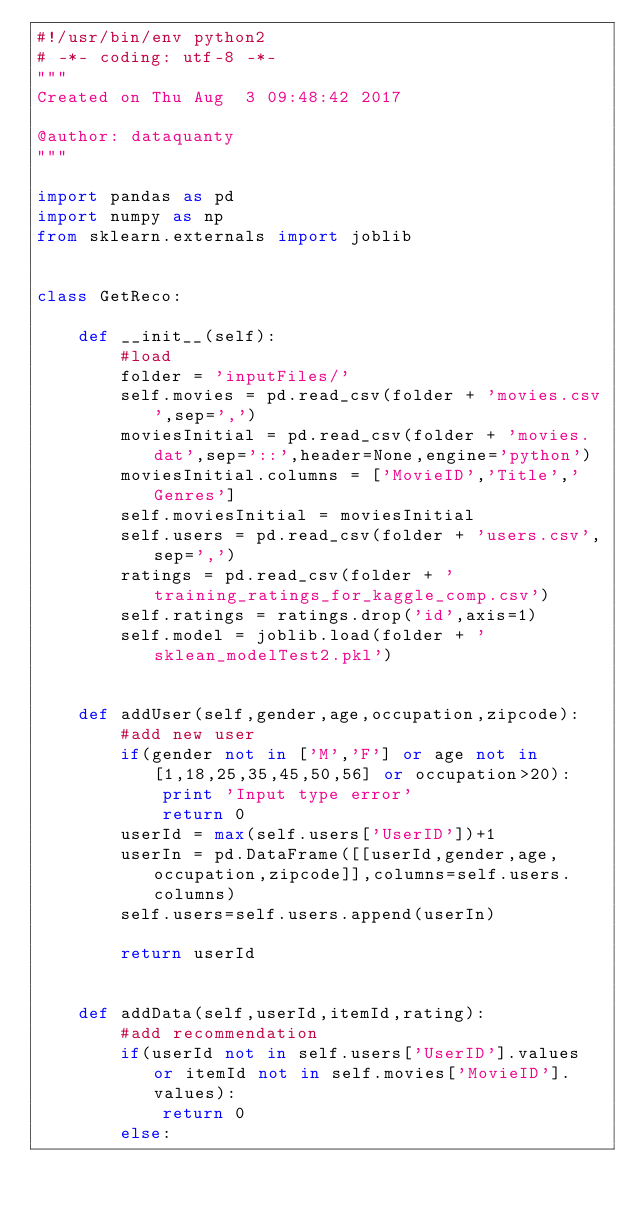<code> <loc_0><loc_0><loc_500><loc_500><_Python_>#!/usr/bin/env python2
# -*- coding: utf-8 -*-
"""
Created on Thu Aug  3 09:48:42 2017

@author: dataquanty
"""

import pandas as pd
import numpy as np
from sklearn.externals import joblib


class GetReco:
        
    def __init__(self):
        #load
        folder = 'inputFiles/'
        self.movies = pd.read_csv(folder + 'movies.csv',sep=',')
        moviesInitial = pd.read_csv(folder + 'movies.dat',sep='::',header=None,engine='python')
        moviesInitial.columns = ['MovieID','Title','Genres']
        self.moviesInitial = moviesInitial
        self.users = pd.read_csv(folder + 'users.csv',sep=',')
        ratings = pd.read_csv(folder + 'training_ratings_for_kaggle_comp.csv')
        self.ratings = ratings.drop('id',axis=1)
        self.model = joblib.load(folder + 'sklean_modelTest2.pkl')
        
        
    def addUser(self,gender,age,occupation,zipcode):
        #add new user
        if(gender not in ['M','F'] or age not in [1,18,25,35,45,50,56] or occupation>20):
            print 'Input type error'
            return 0
        userId = max(self.users['UserID'])+1
        userIn = pd.DataFrame([[userId,gender,age,occupation,zipcode]],columns=self.users.columns)
        self.users=self.users.append(userIn)
        
        return userId
        
    
    def addData(self,userId,itemId,rating):
        #add recommendation
        if(userId not in self.users['UserID'].values or itemId not in self.movies['MovieID'].values):
            return 0
        else:</code> 